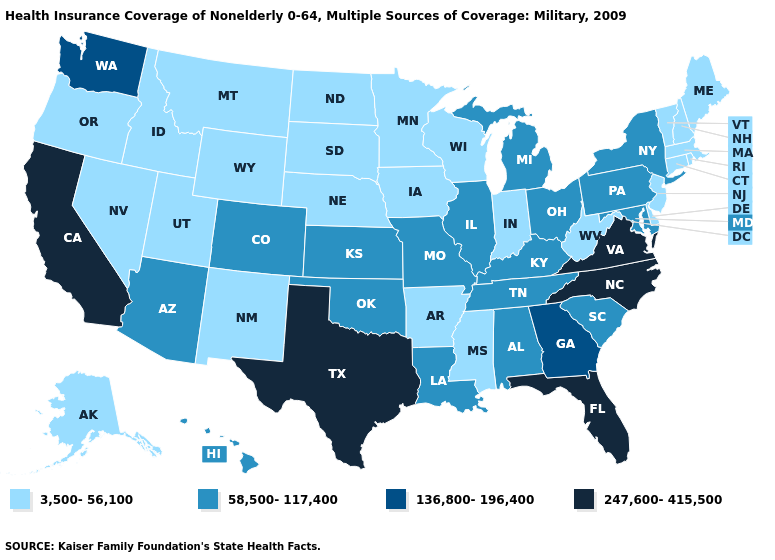Does Ohio have the highest value in the MidWest?
Write a very short answer. Yes. Does North Dakota have the lowest value in the MidWest?
Give a very brief answer. Yes. What is the value of Utah?
Concise answer only. 3,500-56,100. Among the states that border Mississippi , does Louisiana have the lowest value?
Give a very brief answer. No. What is the highest value in states that border Nebraska?
Answer briefly. 58,500-117,400. Among the states that border Kansas , does Nebraska have the highest value?
Write a very short answer. No. Name the states that have a value in the range 58,500-117,400?
Quick response, please. Alabama, Arizona, Colorado, Hawaii, Illinois, Kansas, Kentucky, Louisiana, Maryland, Michigan, Missouri, New York, Ohio, Oklahoma, Pennsylvania, South Carolina, Tennessee. What is the value of New Jersey?
Quick response, please. 3,500-56,100. How many symbols are there in the legend?
Give a very brief answer. 4. Does the map have missing data?
Keep it brief. No. Name the states that have a value in the range 136,800-196,400?
Quick response, please. Georgia, Washington. What is the value of New York?
Be succinct. 58,500-117,400. What is the lowest value in the USA?
Short answer required. 3,500-56,100. What is the lowest value in the South?
Be succinct. 3,500-56,100. Name the states that have a value in the range 136,800-196,400?
Give a very brief answer. Georgia, Washington. 